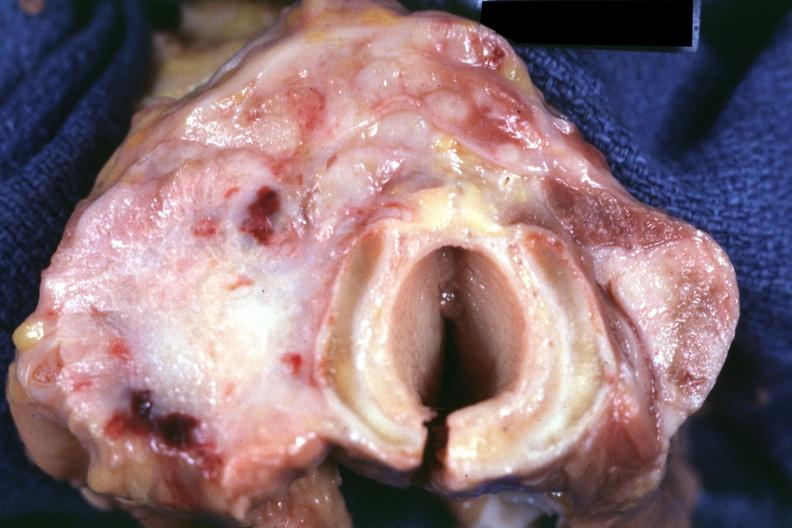how does this image show section through?
Answer the question using a single word or phrase. Thyroid and trachea apparently 